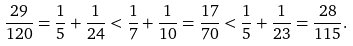<formula> <loc_0><loc_0><loc_500><loc_500>\frac { 2 9 } { 1 2 0 } = \frac { 1 } { 5 } + \frac { 1 } { 2 4 } < \frac { 1 } { 7 } + \frac { 1 } { 1 0 } = \frac { 1 7 } { 7 0 } < \frac { 1 } { 5 } + \frac { 1 } { 2 3 } = \frac { 2 8 } { 1 1 5 } .</formula> 